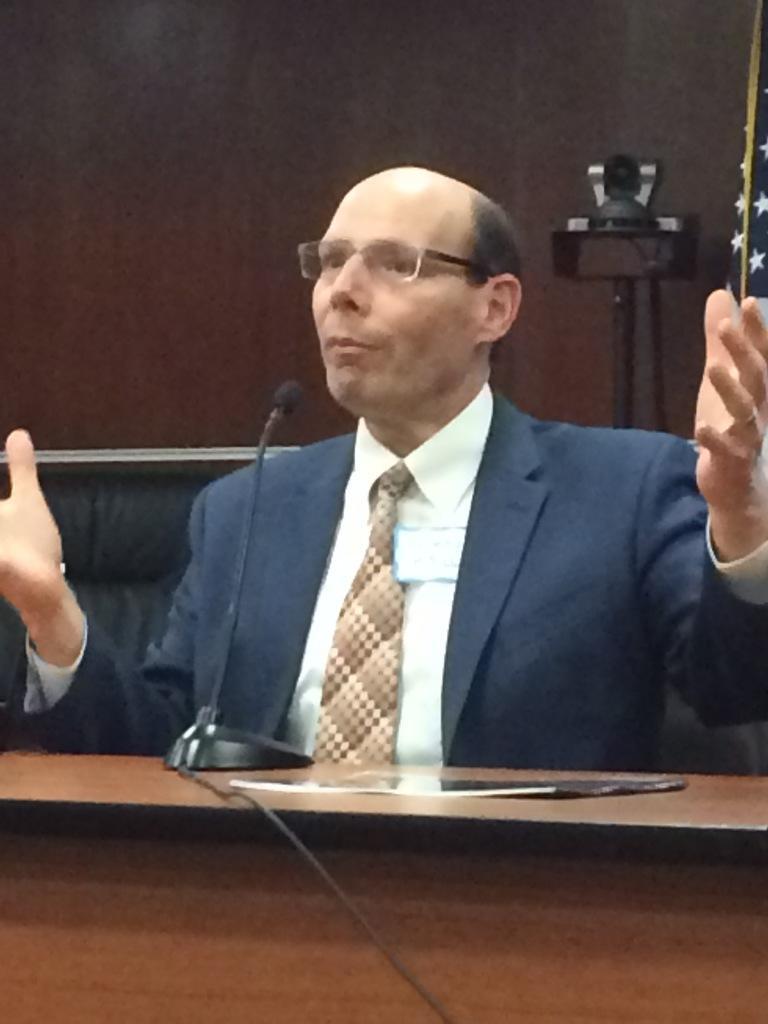Can you describe this image briefly? In this image I see a man who is sitting on the chair and he is in front of the mic. In the background I see the wall and the camera. 